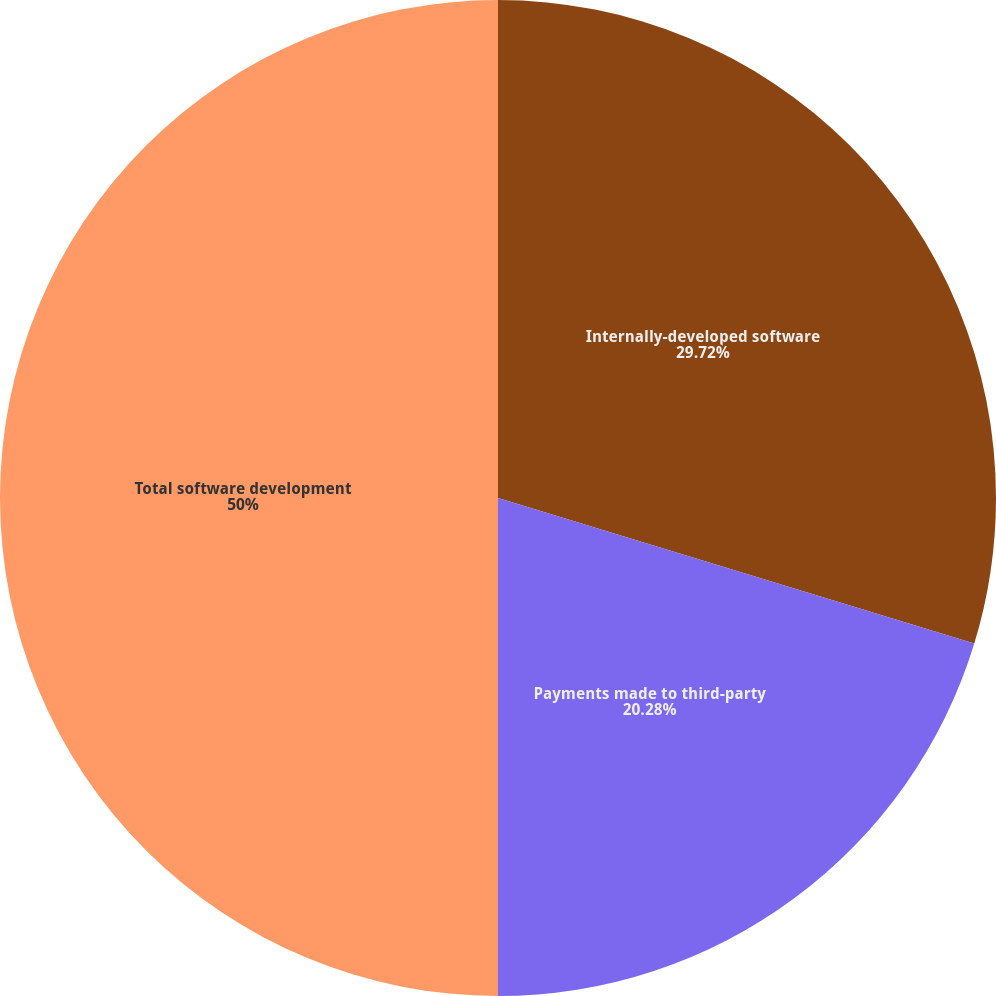Convert chart to OTSL. <chart><loc_0><loc_0><loc_500><loc_500><pie_chart><fcel>Internally-developed software<fcel>Payments made to third-party<fcel>Total software development<nl><fcel>29.72%<fcel>20.28%<fcel>50.0%<nl></chart> 